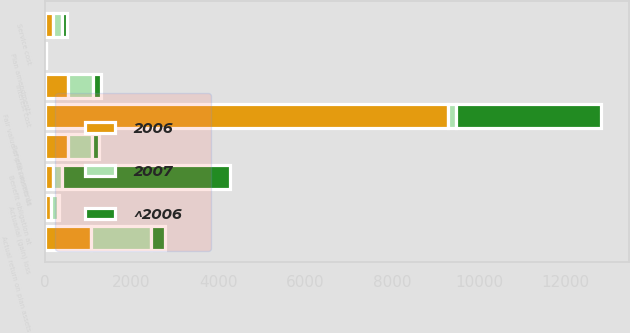Convert chart. <chart><loc_0><loc_0><loc_500><loc_500><stacked_bar_chart><ecel><fcel>Benefit obligation at<fcel>Service cost<fcel>Interest cost<fcel>Plan amendments<fcel>Actuarial (gain) loss<fcel>Benefit payments<fcel>Fair value of plan assets at<fcel>Actual return on plan assets<nl><fcel>2007<fcel>196<fcel>192<fcel>568<fcel>18<fcel>154<fcel>565<fcel>196<fcel>1376<nl><fcel>2006<fcel>196<fcel>196<fcel>539<fcel>2<fcel>142<fcel>530<fcel>9285<fcel>1072<nl><fcel>^2006<fcel>3884<fcel>124<fcel>183<fcel>1<fcel>26<fcel>146<fcel>3340<fcel>325<nl></chart> 